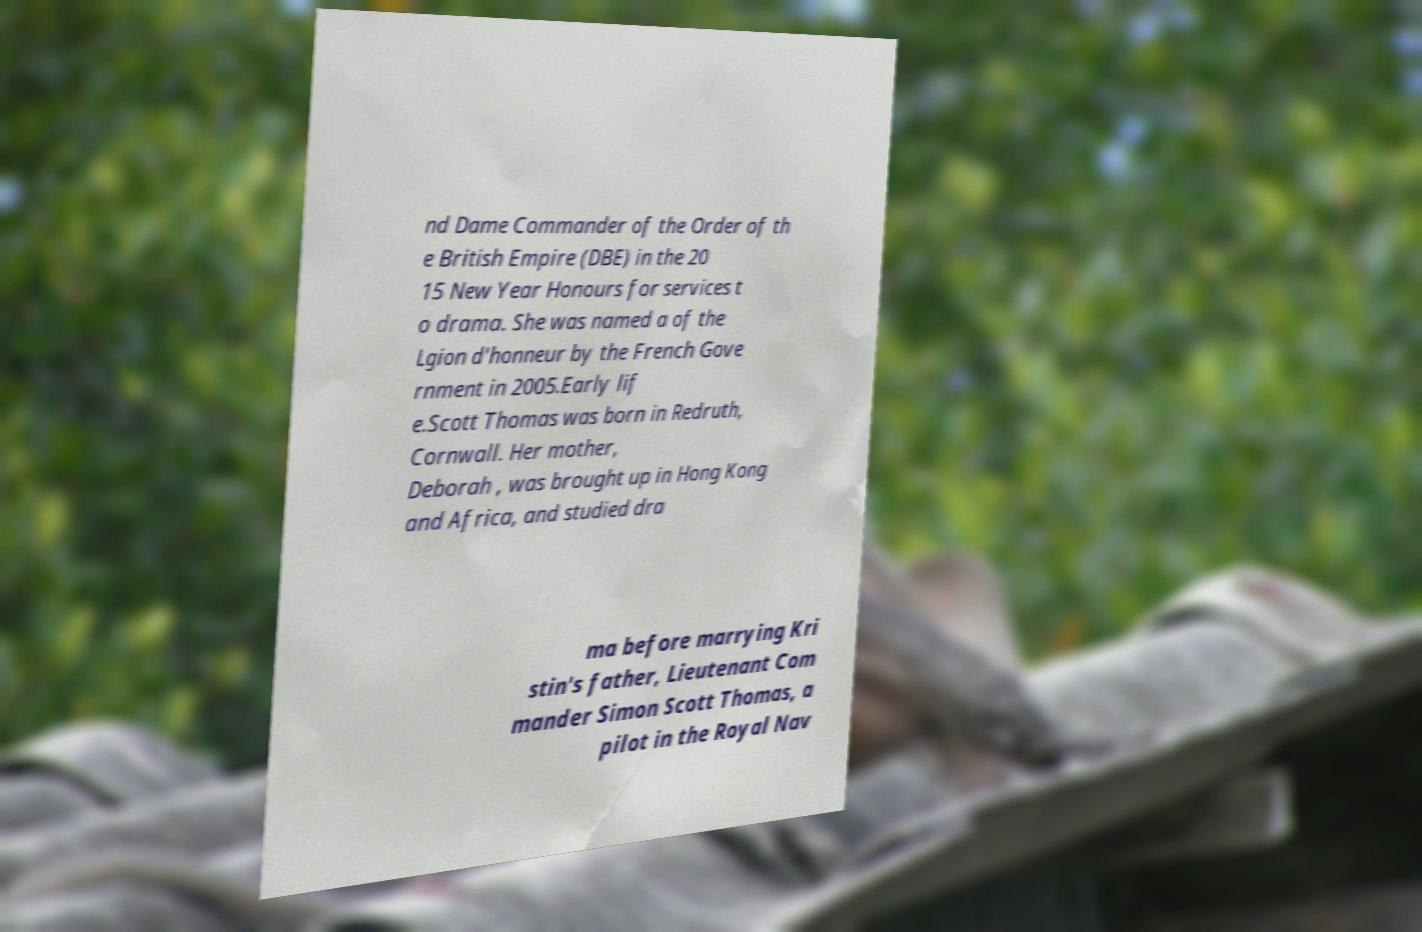Please read and relay the text visible in this image. What does it say? nd Dame Commander of the Order of th e British Empire (DBE) in the 20 15 New Year Honours for services t o drama. She was named a of the Lgion d'honneur by the French Gove rnment in 2005.Early lif e.Scott Thomas was born in Redruth, Cornwall. Her mother, Deborah , was brought up in Hong Kong and Africa, and studied dra ma before marrying Kri stin's father, Lieutenant Com mander Simon Scott Thomas, a pilot in the Royal Nav 